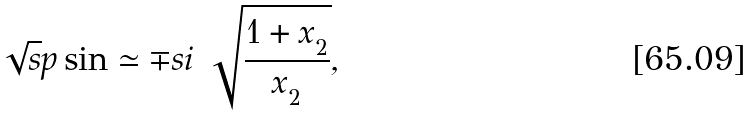Convert formula to latex. <formula><loc_0><loc_0><loc_500><loc_500>\sqrt { s } p \sin \simeq \mp s i \ \sqrt { \frac { 1 + x _ { _ { 2 } } } { x _ { _ { 2 } } } } ,</formula> 